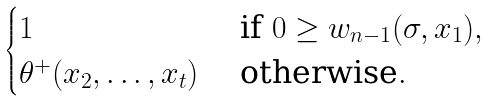<formula> <loc_0><loc_0><loc_500><loc_500>\begin{cases} 1 & \text { if } 0 \geq w _ { n - 1 } ( \sigma , x _ { 1 } ) , \\ \theta ^ { + } ( x _ { 2 } , \dots , x _ { t } ) & \text { otherwise} . \end{cases}</formula> 